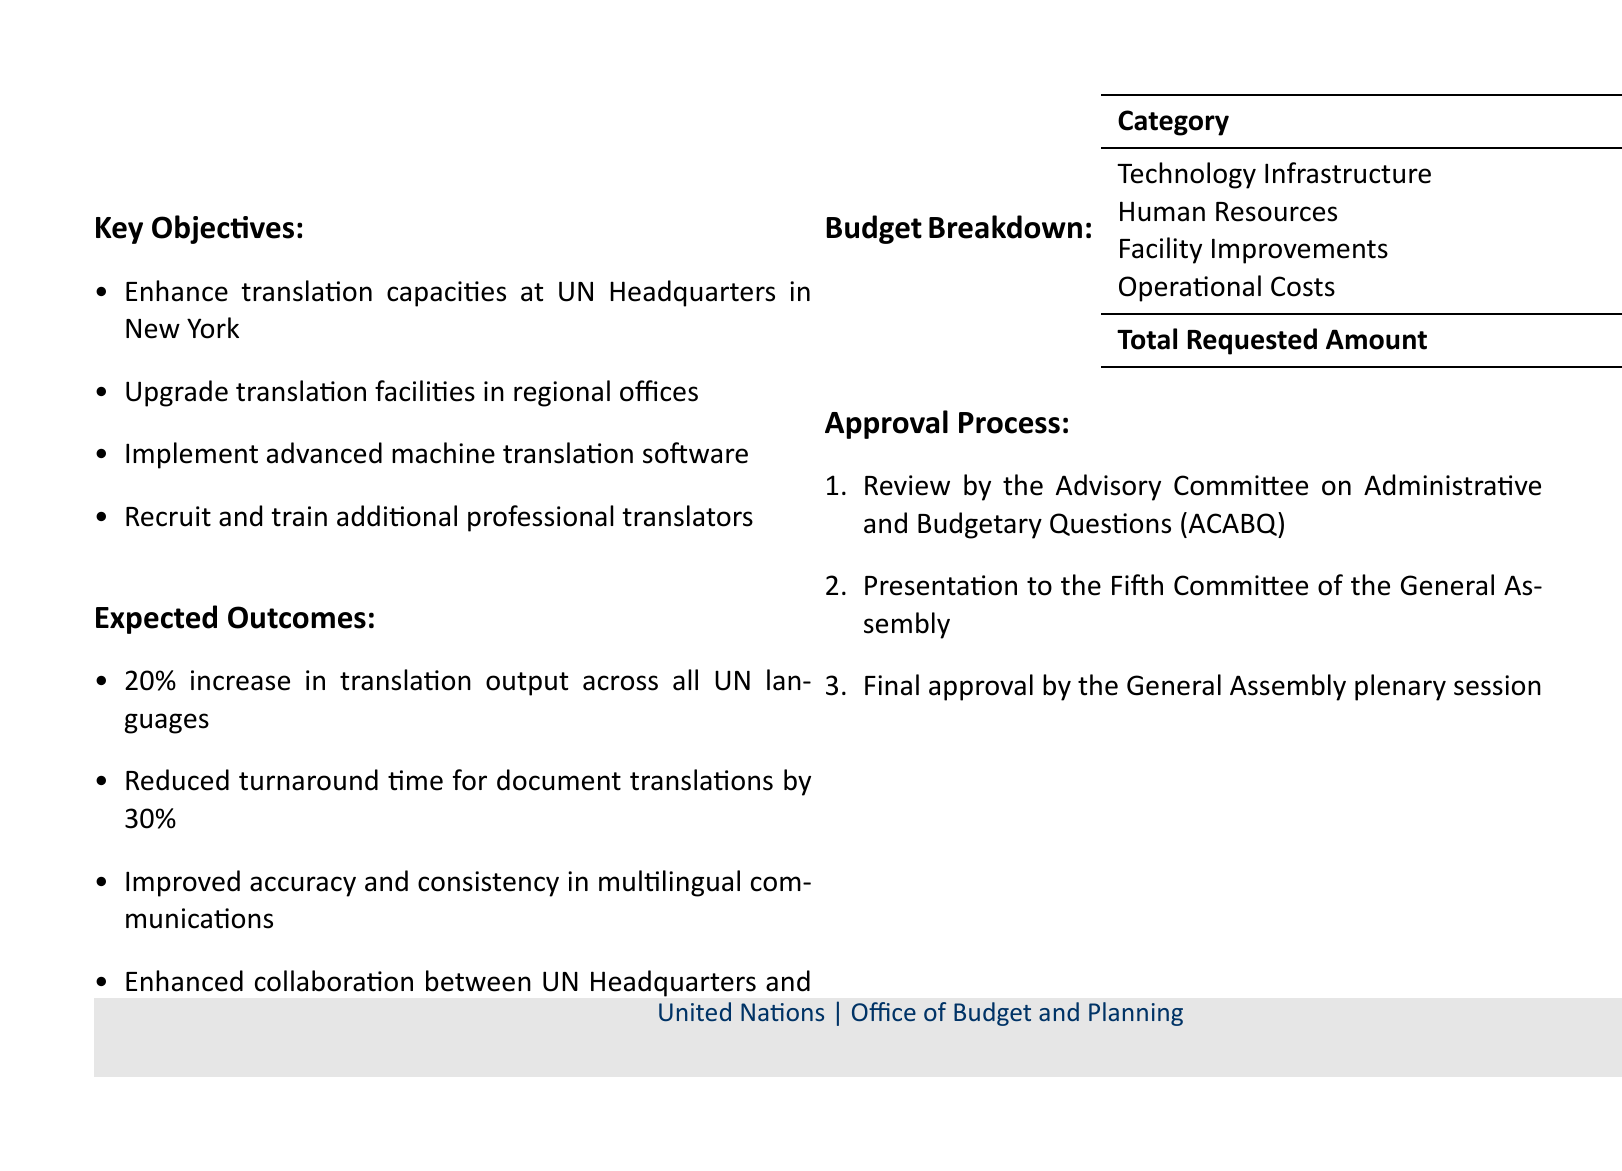What is the total requested amount? The total requested amount is stated in the budget breakdown section of the document.
Answer: $15,750,000 What is the budget for human resources? The human resources budget is detailed in the budget breakdown table.
Answer: $8,500,000 What technology will be implemented? The document specifies the implementation of advanced machine translation software as part of the key objectives.
Answer: Advanced machine translation software By what percentage will translation output increase? The expected outcomes indicate a specific increase in translation output.
Answer: 20% What is the reduction in turnaround time for document translations? The expected outcomes provide a percentage for the turnaround time reduction.
Answer: 30% Which committee reviews the budget proposal first? The approval process outlines the sequence of committees involved in the review.
Answer: Advisory Committee on Administrative and Budgetary Questions (ACABQ) How much is allocated for facility improvements? The budget breakdown lists the amount allocated to facility improvements.
Answer: $1,800,000 What is one of the expected outcomes regarding multilingual communications? The expected outcomes section lists various improvements in multilingual communications.
Answer: Improved accuracy and consistency 